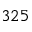<formula> <loc_0><loc_0><loc_500><loc_500>3 2 5</formula> 